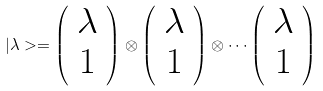Convert formula to latex. <formula><loc_0><loc_0><loc_500><loc_500>| \lambda > = \left ( \begin{array} { c } { \lambda } \\ { 1 } \end{array} \right ) \otimes \left ( \begin{array} { c } { \lambda } \\ { 1 } \end{array} \right ) \otimes \cdots \left ( \begin{array} { c } { \lambda } \\ { 1 } \end{array} \right )</formula> 